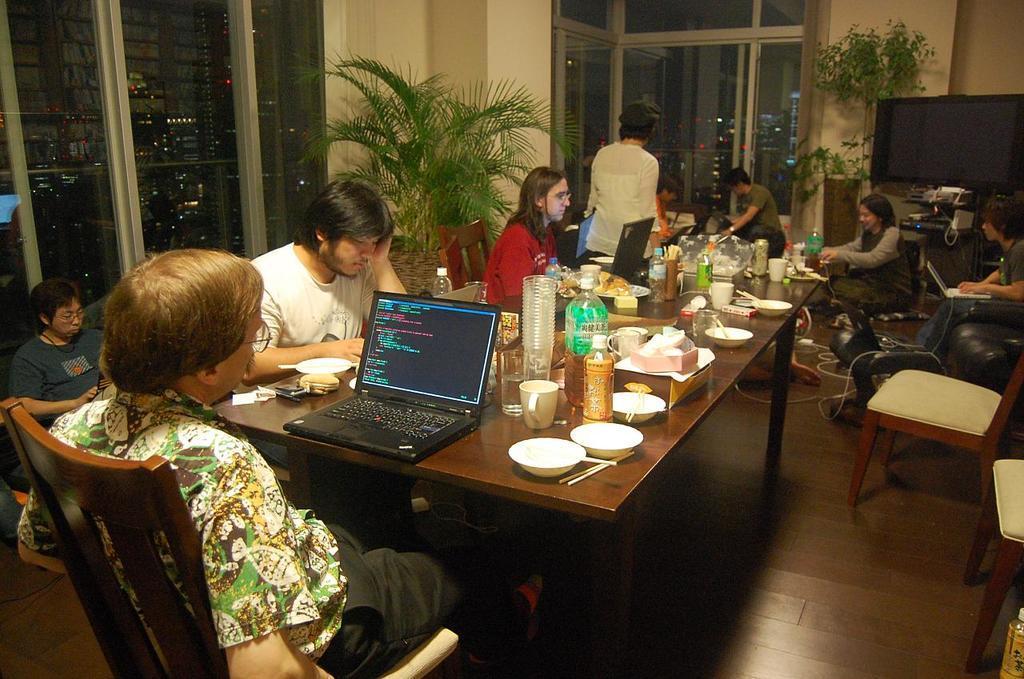How would you summarize this image in a sentence or two? In this picture we can see a group of people sitting on chairs and in front of them on table we have bottles, glasses, laptops, bowls, cup, spoons, plates, mobile and in background we can see window, tree, door,wall, television. 